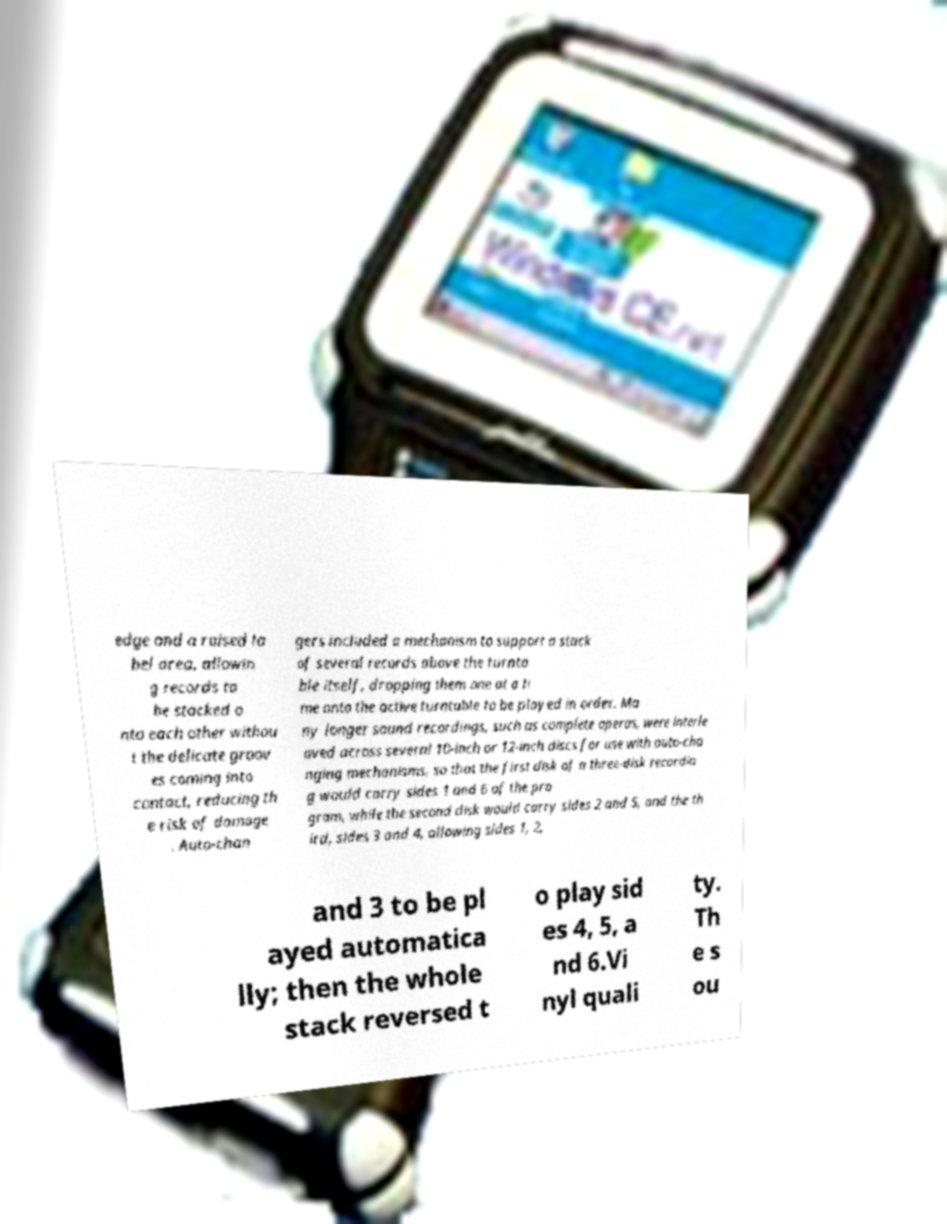What messages or text are displayed in this image? I need them in a readable, typed format. edge and a raised la bel area, allowin g records to be stacked o nto each other withou t the delicate groov es coming into contact, reducing th e risk of damage . Auto-chan gers included a mechanism to support a stack of several records above the turnta ble itself, dropping them one at a ti me onto the active turntable to be played in order. Ma ny longer sound recordings, such as complete operas, were interle aved across several 10-inch or 12-inch discs for use with auto-cha nging mechanisms, so that the first disk of a three-disk recordin g would carry sides 1 and 6 of the pro gram, while the second disk would carry sides 2 and 5, and the th ird, sides 3 and 4, allowing sides 1, 2, and 3 to be pl ayed automatica lly; then the whole stack reversed t o play sid es 4, 5, a nd 6.Vi nyl quali ty. Th e s ou 